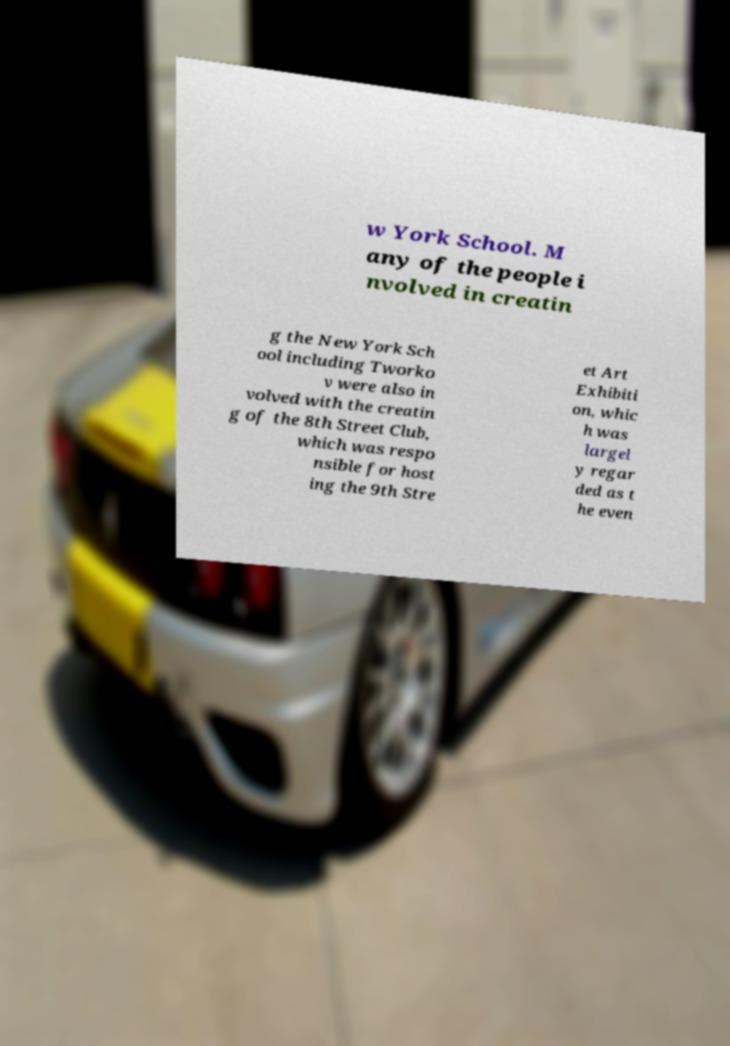What messages or text are displayed in this image? I need them in a readable, typed format. w York School. M any of the people i nvolved in creatin g the New York Sch ool including Tworko v were also in volved with the creatin g of the 8th Street Club, which was respo nsible for host ing the 9th Stre et Art Exhibiti on, whic h was largel y regar ded as t he even 